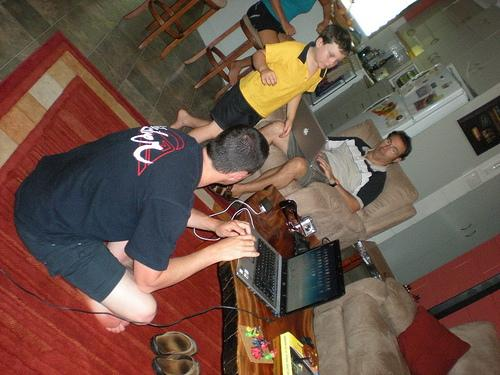What company made the silver laptop the man on the couch is using? Please explain your reasoning. apple. The person is using a macbook. 